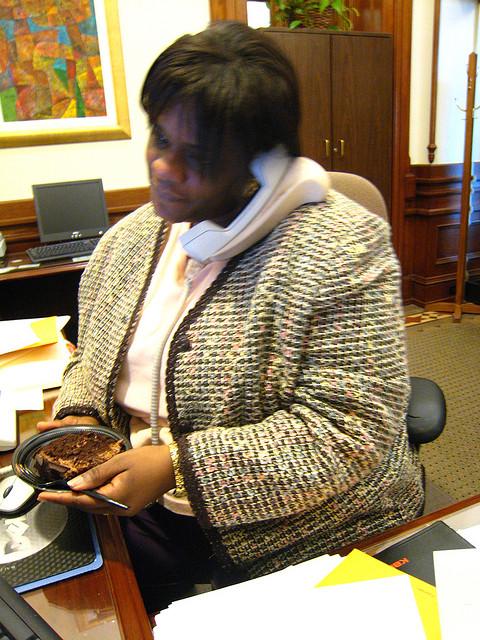Is this a woman?
Quick response, please. Yes. What is next to the woman's ear?
Write a very short answer. Phone. Does this person have natural hair?
Short answer required. Yes. 